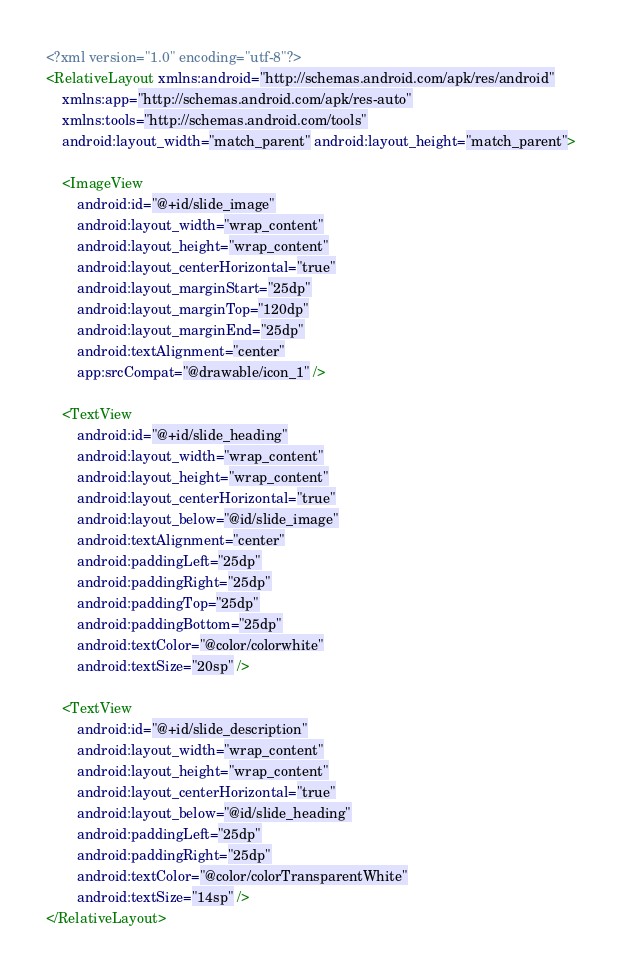<code> <loc_0><loc_0><loc_500><loc_500><_XML_><?xml version="1.0" encoding="utf-8"?>
<RelativeLayout xmlns:android="http://schemas.android.com/apk/res/android"
    xmlns:app="http://schemas.android.com/apk/res-auto"
    xmlns:tools="http://schemas.android.com/tools"
    android:layout_width="match_parent" android:layout_height="match_parent">

    <ImageView
        android:id="@+id/slide_image"
        android:layout_width="wrap_content"
        android:layout_height="wrap_content"
        android:layout_centerHorizontal="true"
        android:layout_marginStart="25dp"
        android:layout_marginTop="120dp"
        android:layout_marginEnd="25dp"
        android:textAlignment="center"
        app:srcCompat="@drawable/icon_1" />

    <TextView
        android:id="@+id/slide_heading"
        android:layout_width="wrap_content"
        android:layout_height="wrap_content"
        android:layout_centerHorizontal="true"
        android:layout_below="@id/slide_image"
        android:textAlignment="center"
        android:paddingLeft="25dp"
        android:paddingRight="25dp"
        android:paddingTop="25dp"
        android:paddingBottom="25dp"
        android:textColor="@color/colorwhite"
        android:textSize="20sp" />

    <TextView
        android:id="@+id/slide_description"
        android:layout_width="wrap_content"
        android:layout_height="wrap_content"
        android:layout_centerHorizontal="true"
        android:layout_below="@id/slide_heading"
        android:paddingLeft="25dp"
        android:paddingRight="25dp"
        android:textColor="@color/colorTransparentWhite"
        android:textSize="14sp" />
</RelativeLayout></code> 